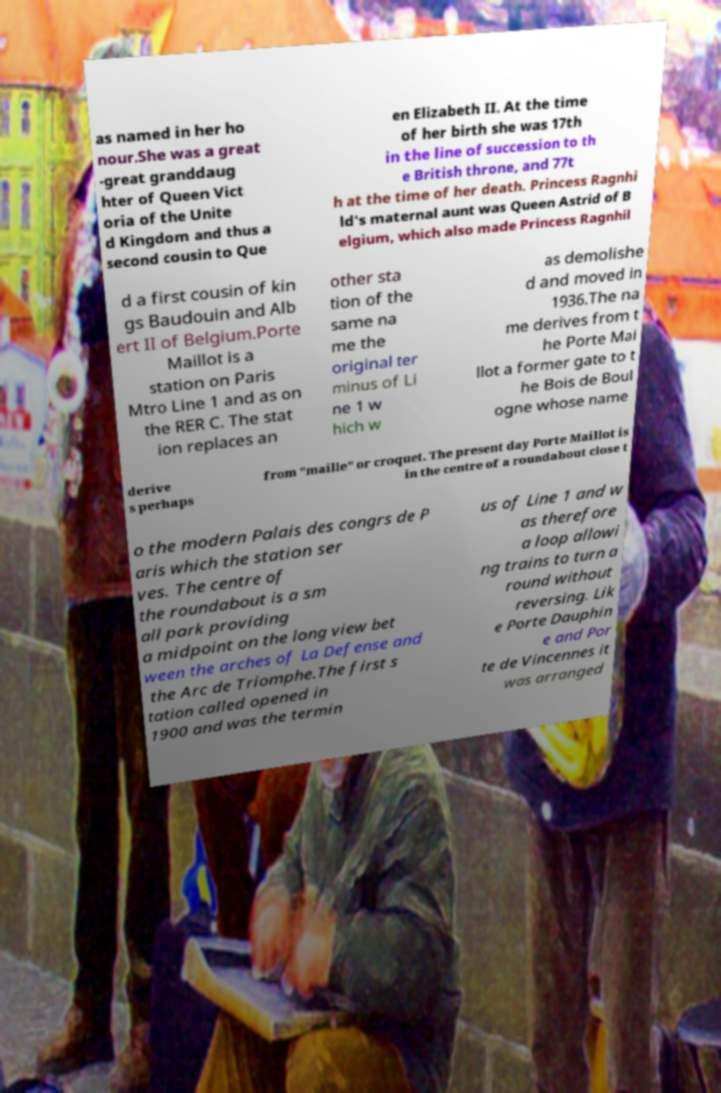Could you extract and type out the text from this image? as named in her ho nour.She was a great -great granddaug hter of Queen Vict oria of the Unite d Kingdom and thus a second cousin to Que en Elizabeth II. At the time of her birth she was 17th in the line of succession to th e British throne, and 77t h at the time of her death. Princess Ragnhi ld's maternal aunt was Queen Astrid of B elgium, which also made Princess Ragnhil d a first cousin of kin gs Baudouin and Alb ert II of Belgium.Porte Maillot is a station on Paris Mtro Line 1 and as on the RER C. The stat ion replaces an other sta tion of the same na me the original ter minus of Li ne 1 w hich w as demolishe d and moved in 1936.The na me derives from t he Porte Mai llot a former gate to t he Bois de Boul ogne whose name derive s perhaps from "maille" or croquet. The present day Porte Maillot is in the centre of a roundabout close t o the modern Palais des congrs de P aris which the station ser ves. The centre of the roundabout is a sm all park providing a midpoint on the long view bet ween the arches of La Defense and the Arc de Triomphe.The first s tation called opened in 1900 and was the termin us of Line 1 and w as therefore a loop allowi ng trains to turn a round without reversing. Lik e Porte Dauphin e and Por te de Vincennes it was arranged 